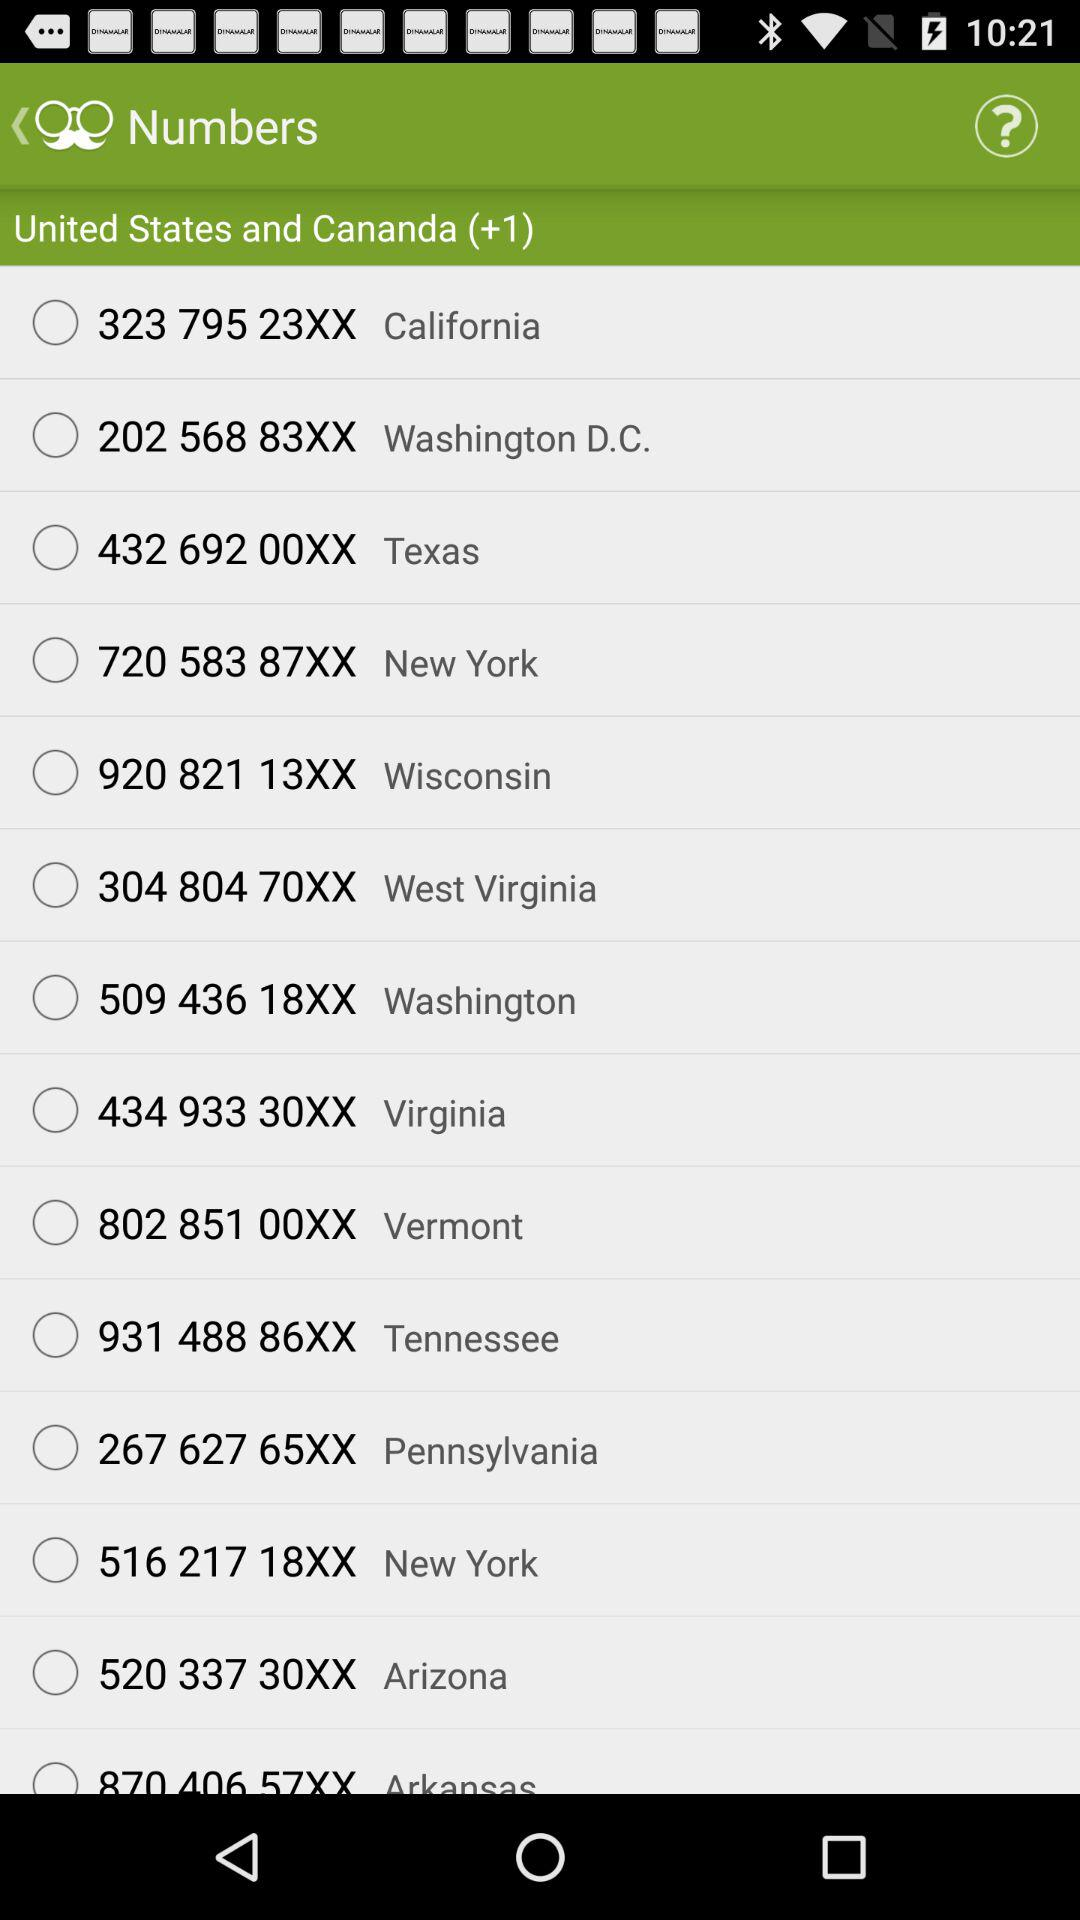What is the number for Vermont? The number is 802 851 00XX. 